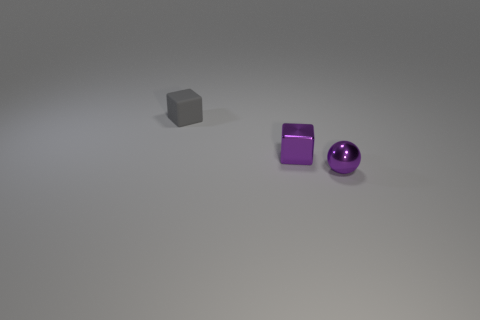Are there any other things that are the same material as the tiny gray block?
Make the answer very short. No. There is another object that is the same shape as the tiny gray matte object; what color is it?
Keep it short and to the point. Purple. Is the number of small purple objects on the left side of the purple cube greater than the number of gray rubber cubes that are in front of the purple shiny ball?
Your answer should be very brief. No. There is a cube in front of the gray block; is there a tiny cube that is right of it?
Keep it short and to the point. No. What number of cyan metal balls are there?
Provide a succinct answer. 0. There is a tiny sphere; is its color the same as the shiny thing that is to the left of the tiny shiny ball?
Your answer should be compact. Yes. Are there more gray cubes than blocks?
Your answer should be compact. No. Are there any other things that have the same color as the tiny rubber cube?
Ensure brevity in your answer.  No. What number of other things are the same size as the gray matte object?
Your response must be concise. 2. There is a thing to the left of the tiny cube in front of the tiny block that is behind the tiny purple block; what is it made of?
Your answer should be compact. Rubber. 